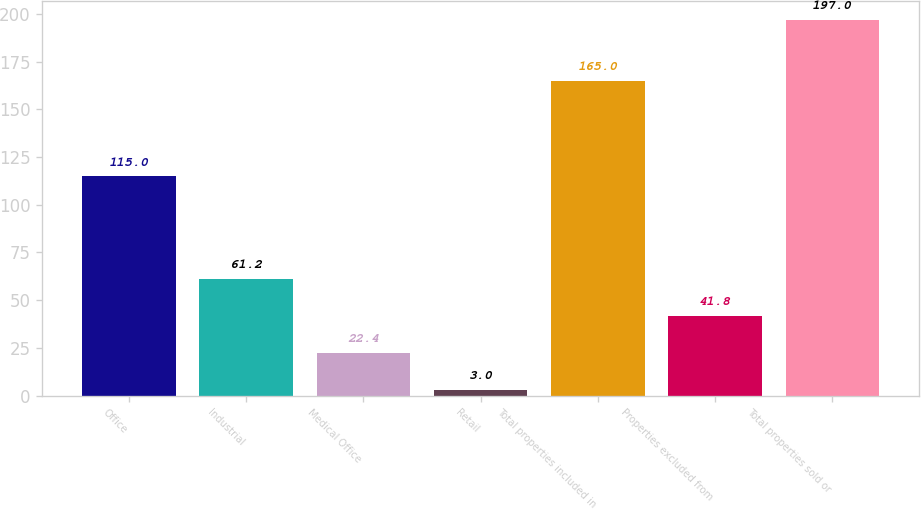<chart> <loc_0><loc_0><loc_500><loc_500><bar_chart><fcel>Office<fcel>Industrial<fcel>Medical Office<fcel>Retail<fcel>Total properties included in<fcel>Properties excluded from<fcel>Total properties sold or<nl><fcel>115<fcel>61.2<fcel>22.4<fcel>3<fcel>165<fcel>41.8<fcel>197<nl></chart> 